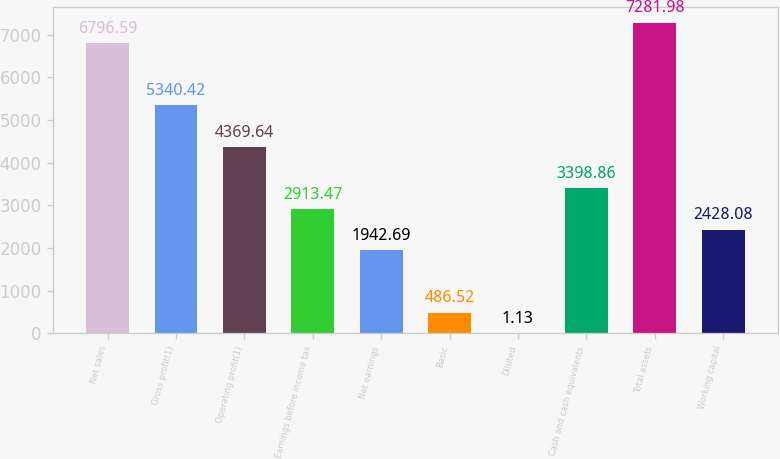<chart> <loc_0><loc_0><loc_500><loc_500><bar_chart><fcel>Net sales<fcel>Gross profit(1)<fcel>Operating profit(1)<fcel>Earnings before income tax<fcel>Net earnings<fcel>Basic<fcel>Diluted<fcel>Cash and cash equivalents<fcel>Total assets<fcel>Working capital<nl><fcel>6796.59<fcel>5340.42<fcel>4369.64<fcel>2913.47<fcel>1942.69<fcel>486.52<fcel>1.13<fcel>3398.86<fcel>7281.98<fcel>2428.08<nl></chart> 